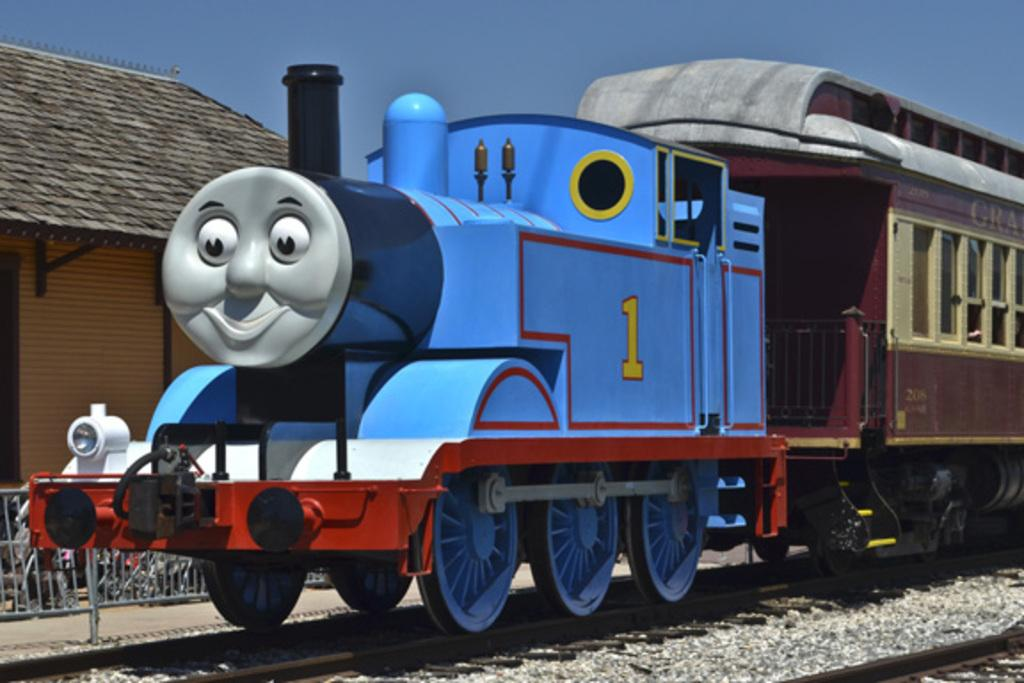<image>
Render a clear and concise summary of the photo. The engine of a blue train has the number 1 shown on its side. 